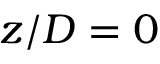<formula> <loc_0><loc_0><loc_500><loc_500>z / D = 0</formula> 